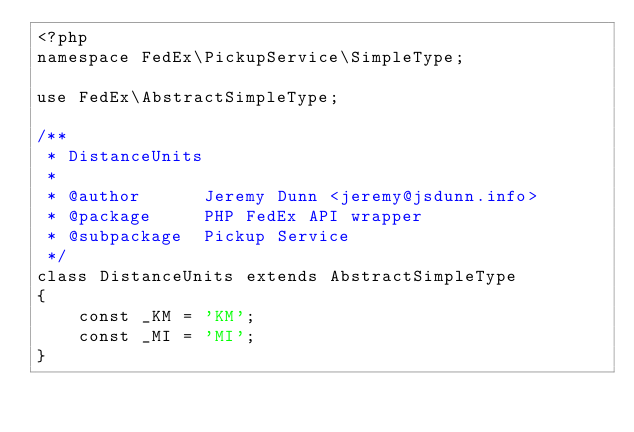Convert code to text. <code><loc_0><loc_0><loc_500><loc_500><_PHP_><?php
namespace FedEx\PickupService\SimpleType;

use FedEx\AbstractSimpleType;

/**
 * DistanceUnits
 *
 * @author      Jeremy Dunn <jeremy@jsdunn.info>
 * @package     PHP FedEx API wrapper
 * @subpackage  Pickup Service
 */
class DistanceUnits extends AbstractSimpleType
{
    const _KM = 'KM';
    const _MI = 'MI';
}
</code> 